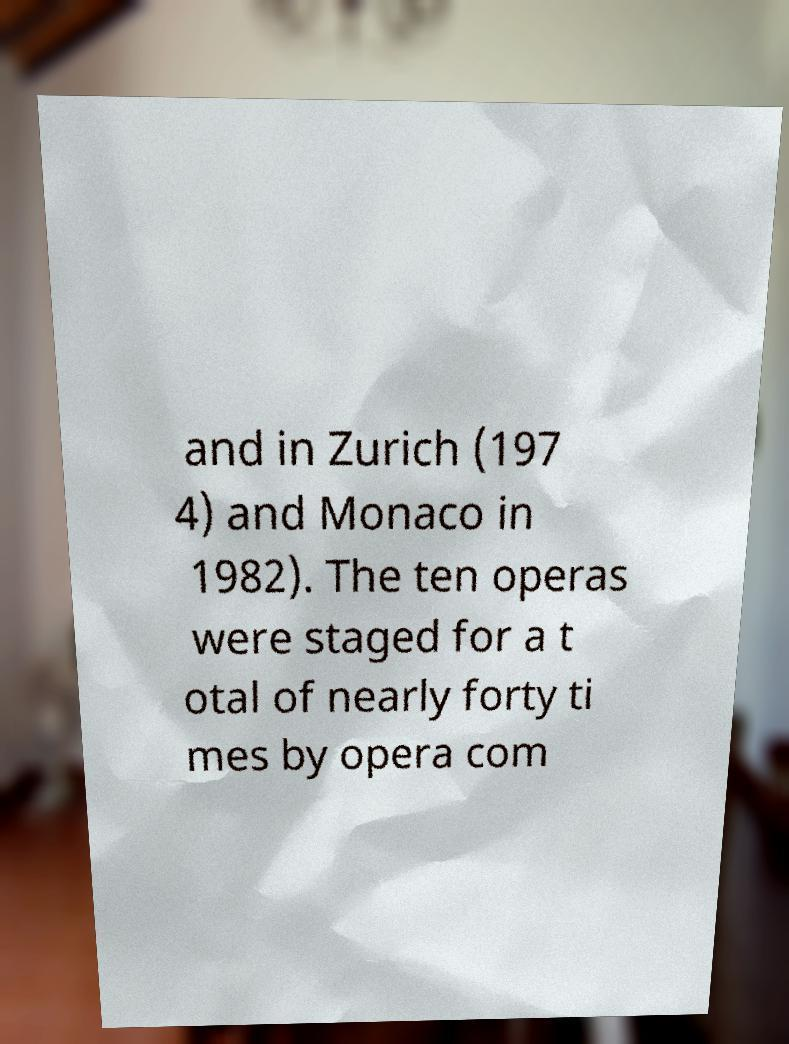Could you extract and type out the text from this image? and in Zurich (197 4) and Monaco in 1982). The ten operas were staged for a t otal of nearly forty ti mes by opera com 